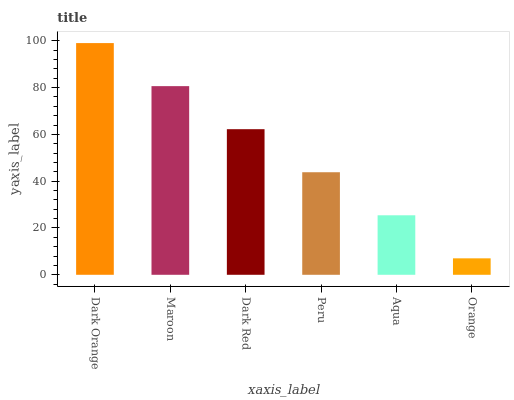Is Orange the minimum?
Answer yes or no. Yes. Is Dark Orange the maximum?
Answer yes or no. Yes. Is Maroon the minimum?
Answer yes or no. No. Is Maroon the maximum?
Answer yes or no. No. Is Dark Orange greater than Maroon?
Answer yes or no. Yes. Is Maroon less than Dark Orange?
Answer yes or no. Yes. Is Maroon greater than Dark Orange?
Answer yes or no. No. Is Dark Orange less than Maroon?
Answer yes or no. No. Is Dark Red the high median?
Answer yes or no. Yes. Is Peru the low median?
Answer yes or no. Yes. Is Dark Orange the high median?
Answer yes or no. No. Is Orange the low median?
Answer yes or no. No. 